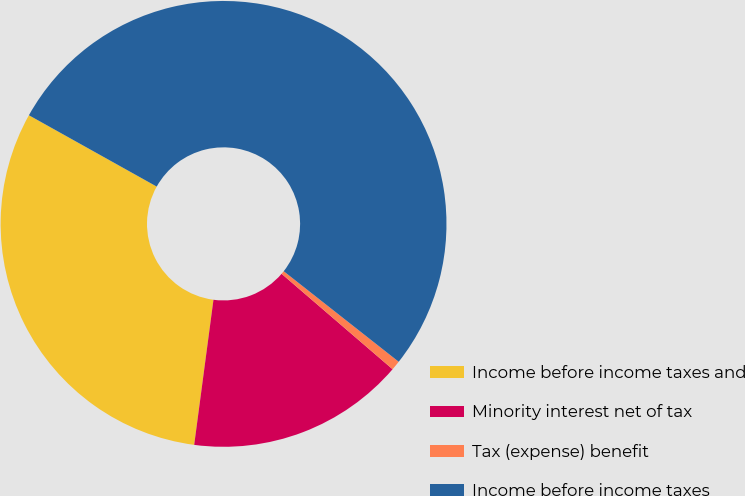Convert chart. <chart><loc_0><loc_0><loc_500><loc_500><pie_chart><fcel>Income before income taxes and<fcel>Minority interest net of tax<fcel>Tax (expense) benefit<fcel>Income before income taxes<nl><fcel>31.0%<fcel>15.8%<fcel>0.69%<fcel>52.51%<nl></chart> 